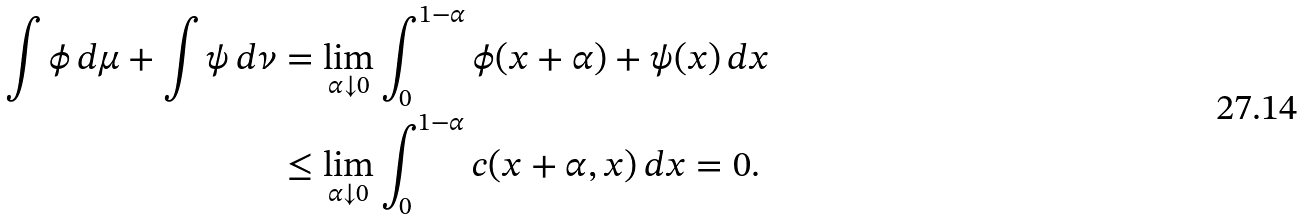Convert formula to latex. <formula><loc_0><loc_0><loc_500><loc_500>\int \phi \, d \mu + \int \psi \, d \nu & = \lim _ { \alpha \downarrow 0 } \int _ { 0 } ^ { 1 - \alpha } \phi ( x + \alpha ) + \psi ( x ) \, d x \\ & \leq \lim _ { \alpha \downarrow 0 } \int _ { 0 } ^ { 1 - \alpha } c ( x + \alpha , x ) \, d x = 0 .</formula> 